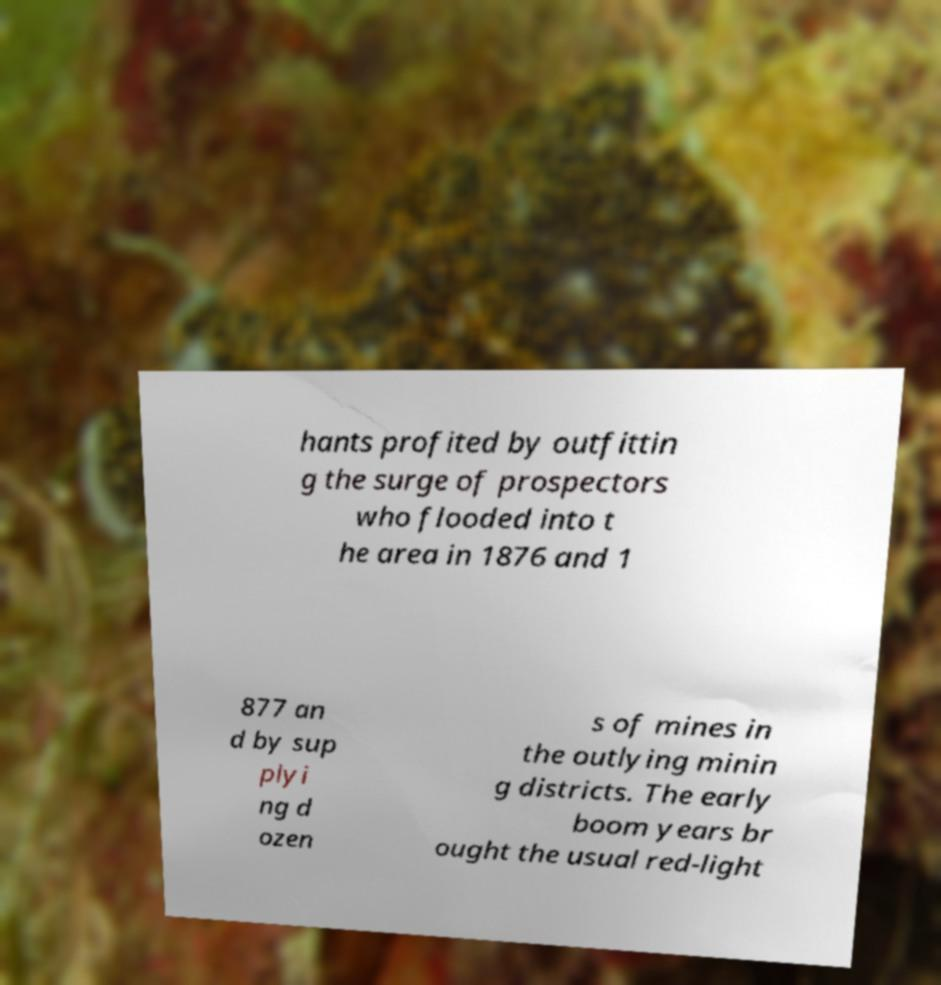Could you assist in decoding the text presented in this image and type it out clearly? hants profited by outfittin g the surge of prospectors who flooded into t he area in 1876 and 1 877 an d by sup plyi ng d ozen s of mines in the outlying minin g districts. The early boom years br ought the usual red-light 